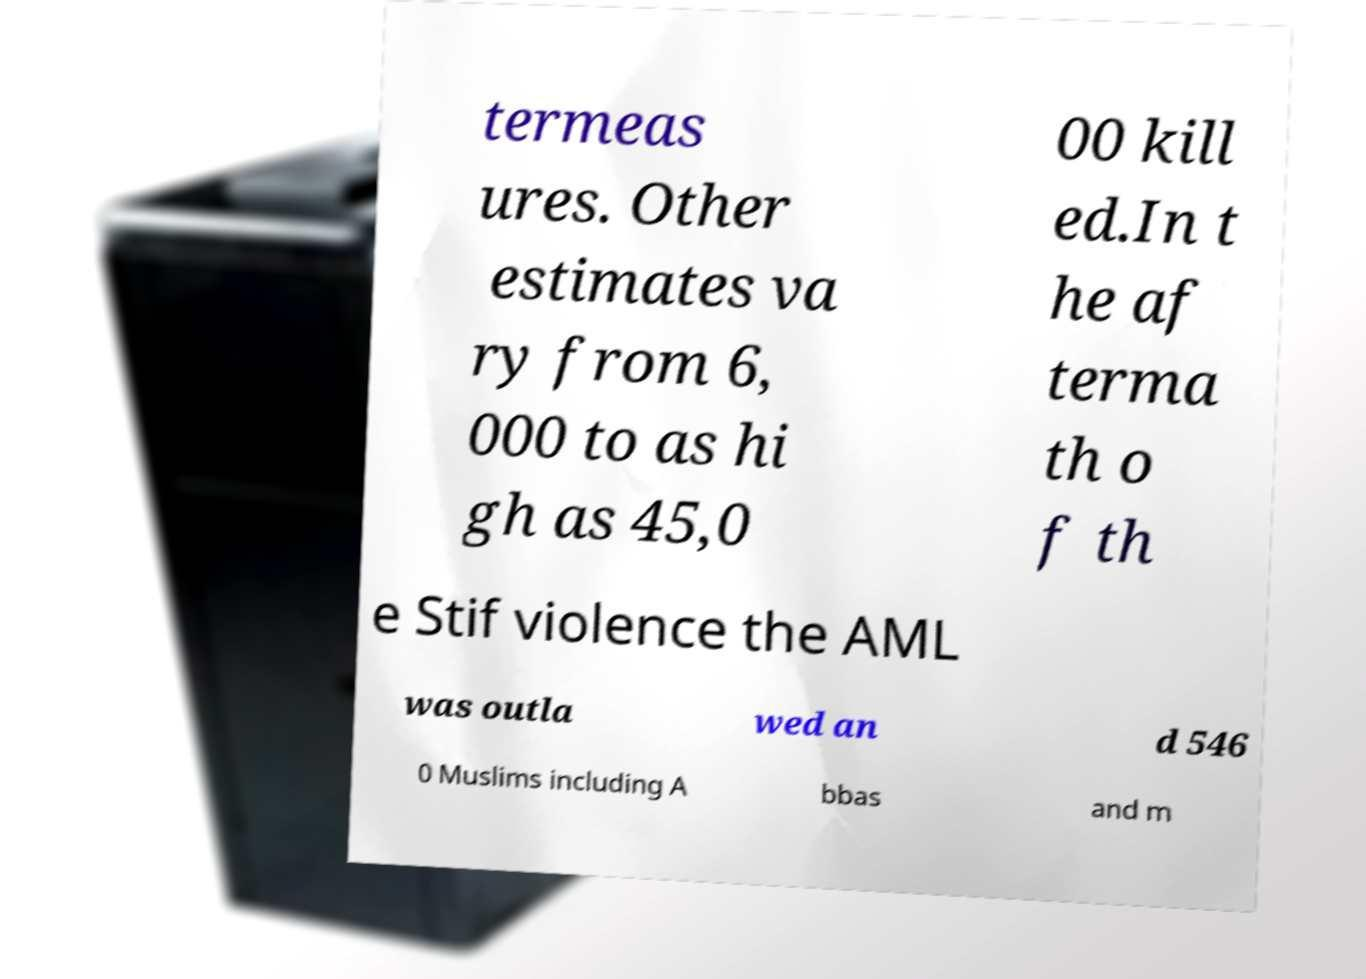For documentation purposes, I need the text within this image transcribed. Could you provide that? termeas ures. Other estimates va ry from 6, 000 to as hi gh as 45,0 00 kill ed.In t he af terma th o f th e Stif violence the AML was outla wed an d 546 0 Muslims including A bbas and m 